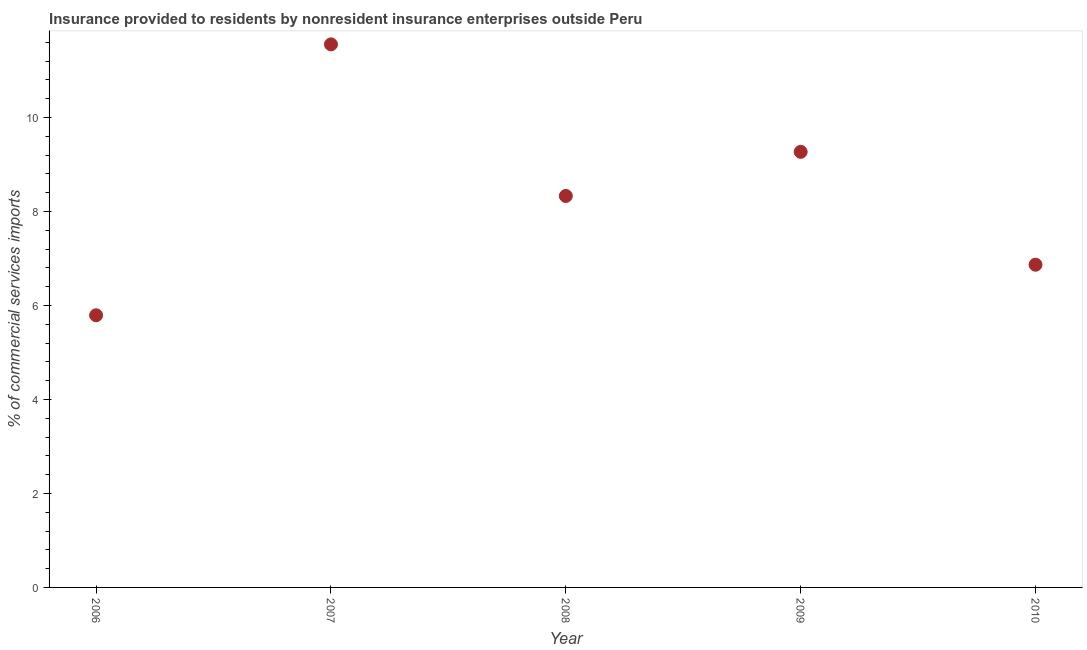What is the insurance provided by non-residents in 2006?
Ensure brevity in your answer.  5.79. Across all years, what is the maximum insurance provided by non-residents?
Offer a terse response. 11.56. Across all years, what is the minimum insurance provided by non-residents?
Provide a succinct answer. 5.79. In which year was the insurance provided by non-residents maximum?
Offer a terse response. 2007. What is the sum of the insurance provided by non-residents?
Your answer should be very brief. 41.81. What is the difference between the insurance provided by non-residents in 2006 and 2008?
Make the answer very short. -2.54. What is the average insurance provided by non-residents per year?
Provide a short and direct response. 8.36. What is the median insurance provided by non-residents?
Keep it short and to the point. 8.33. What is the ratio of the insurance provided by non-residents in 2006 to that in 2010?
Ensure brevity in your answer.  0.84. Is the difference between the insurance provided by non-residents in 2006 and 2007 greater than the difference between any two years?
Your answer should be compact. Yes. What is the difference between the highest and the second highest insurance provided by non-residents?
Your response must be concise. 2.29. Is the sum of the insurance provided by non-residents in 2008 and 2009 greater than the maximum insurance provided by non-residents across all years?
Give a very brief answer. Yes. What is the difference between the highest and the lowest insurance provided by non-residents?
Your response must be concise. 5.76. How many dotlines are there?
Provide a succinct answer. 1. How many years are there in the graph?
Offer a terse response. 5. Are the values on the major ticks of Y-axis written in scientific E-notation?
Your response must be concise. No. Does the graph contain any zero values?
Your answer should be compact. No. What is the title of the graph?
Your answer should be very brief. Insurance provided to residents by nonresident insurance enterprises outside Peru. What is the label or title of the X-axis?
Provide a succinct answer. Year. What is the label or title of the Y-axis?
Keep it short and to the point. % of commercial services imports. What is the % of commercial services imports in 2006?
Your answer should be very brief. 5.79. What is the % of commercial services imports in 2007?
Give a very brief answer. 11.56. What is the % of commercial services imports in 2008?
Provide a short and direct response. 8.33. What is the % of commercial services imports in 2009?
Make the answer very short. 9.27. What is the % of commercial services imports in 2010?
Your answer should be compact. 6.87. What is the difference between the % of commercial services imports in 2006 and 2007?
Your response must be concise. -5.76. What is the difference between the % of commercial services imports in 2006 and 2008?
Your answer should be compact. -2.54. What is the difference between the % of commercial services imports in 2006 and 2009?
Ensure brevity in your answer.  -3.48. What is the difference between the % of commercial services imports in 2006 and 2010?
Make the answer very short. -1.08. What is the difference between the % of commercial services imports in 2007 and 2008?
Ensure brevity in your answer.  3.23. What is the difference between the % of commercial services imports in 2007 and 2009?
Provide a short and direct response. 2.29. What is the difference between the % of commercial services imports in 2007 and 2010?
Your response must be concise. 4.69. What is the difference between the % of commercial services imports in 2008 and 2009?
Offer a very short reply. -0.94. What is the difference between the % of commercial services imports in 2008 and 2010?
Keep it short and to the point. 1.46. What is the difference between the % of commercial services imports in 2009 and 2010?
Ensure brevity in your answer.  2.4. What is the ratio of the % of commercial services imports in 2006 to that in 2007?
Offer a terse response. 0.5. What is the ratio of the % of commercial services imports in 2006 to that in 2008?
Make the answer very short. 0.69. What is the ratio of the % of commercial services imports in 2006 to that in 2010?
Make the answer very short. 0.84. What is the ratio of the % of commercial services imports in 2007 to that in 2008?
Make the answer very short. 1.39. What is the ratio of the % of commercial services imports in 2007 to that in 2009?
Offer a very short reply. 1.25. What is the ratio of the % of commercial services imports in 2007 to that in 2010?
Your response must be concise. 1.68. What is the ratio of the % of commercial services imports in 2008 to that in 2009?
Keep it short and to the point. 0.9. What is the ratio of the % of commercial services imports in 2008 to that in 2010?
Give a very brief answer. 1.21. What is the ratio of the % of commercial services imports in 2009 to that in 2010?
Ensure brevity in your answer.  1.35. 